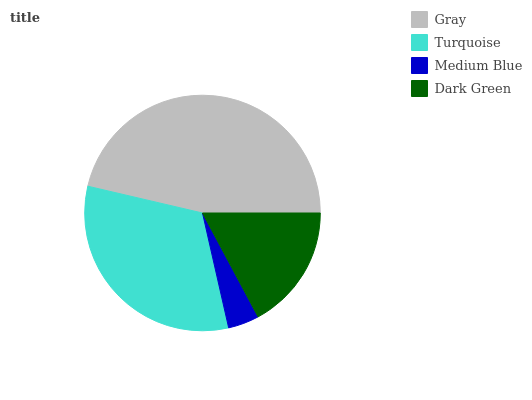Is Medium Blue the minimum?
Answer yes or no. Yes. Is Gray the maximum?
Answer yes or no. Yes. Is Turquoise the minimum?
Answer yes or no. No. Is Turquoise the maximum?
Answer yes or no. No. Is Gray greater than Turquoise?
Answer yes or no. Yes. Is Turquoise less than Gray?
Answer yes or no. Yes. Is Turquoise greater than Gray?
Answer yes or no. No. Is Gray less than Turquoise?
Answer yes or no. No. Is Turquoise the high median?
Answer yes or no. Yes. Is Dark Green the low median?
Answer yes or no. Yes. Is Medium Blue the high median?
Answer yes or no. No. Is Medium Blue the low median?
Answer yes or no. No. 